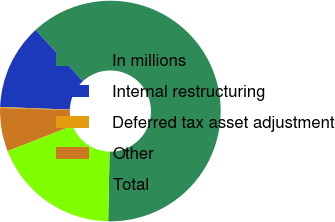<chart> <loc_0><loc_0><loc_500><loc_500><pie_chart><fcel>In millions<fcel>Internal restructuring<fcel>Deferred tax asset adjustment<fcel>Other<fcel>Total<nl><fcel>62.17%<fcel>12.56%<fcel>0.15%<fcel>6.36%<fcel>18.76%<nl></chart> 